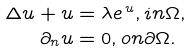<formula> <loc_0><loc_0><loc_500><loc_500>\Delta u + u & = \lambda e ^ { \, u } , i n \Omega , \\ \partial _ { n } u & = 0 , o n \partial \Omega .</formula> 